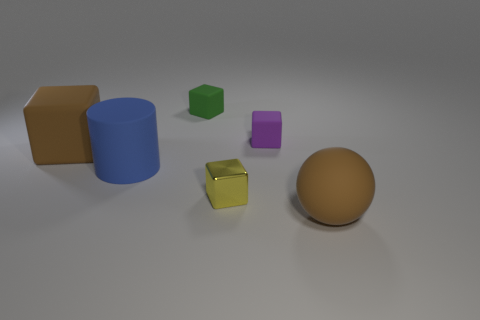Subtract all green cubes. Subtract all brown balls. How many cubes are left? 3 Add 2 big brown objects. How many objects exist? 8 Subtract all cylinders. How many objects are left? 5 Add 5 big purple spheres. How many big purple spheres exist? 5 Subtract 0 red spheres. How many objects are left? 6 Subtract all green rubber cubes. Subtract all large rubber cylinders. How many objects are left? 4 Add 6 small purple things. How many small purple things are left? 7 